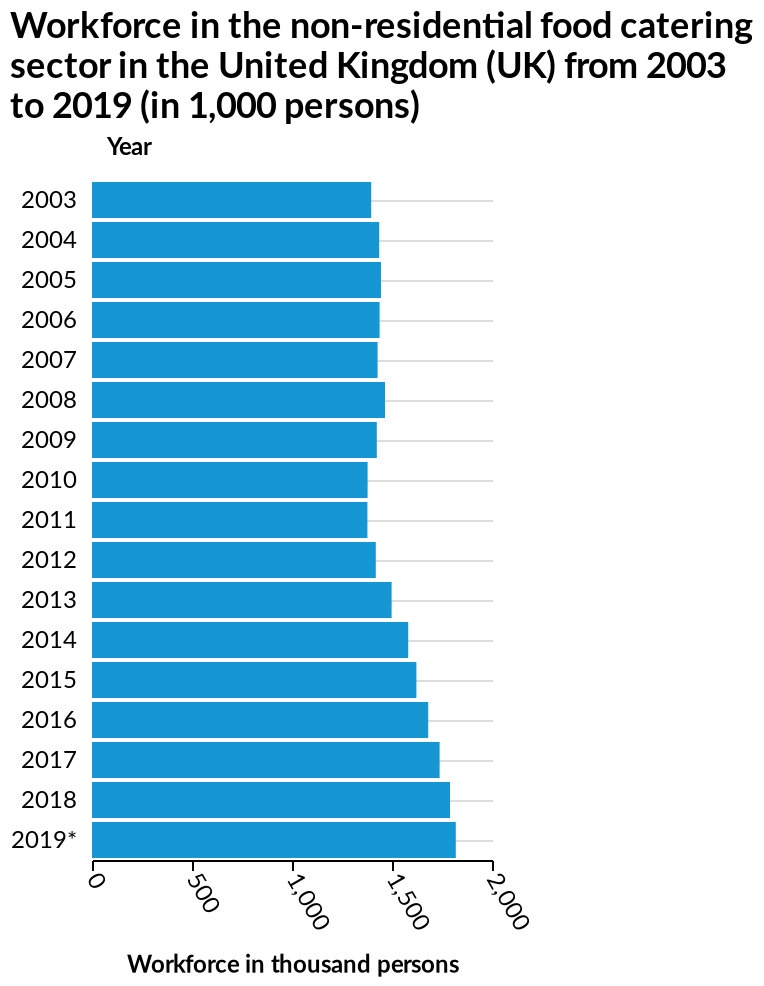<image>
What is the title of the bar graph?  The title of the bar graph is "Workforce in the non-residential food catering sector in the United Kingdom (UK) from 2003 to 2019 (in 1,000 persons)". Has the increase in the number of workforce been consistent over the years?  Yes, overall, there has been a consistent increase in the number of workforce over the years. What does the x-axis in the bar graph measure?  The x-axis in the bar graph measures Workforce in thousand persons. What does the y-axis in the bar graph plot?  The y-axis in the bar graph plots Year. Was there a decline in the number of workforce in 2010 and 2011?  Yes, there was a dip in the number of workforce in both 2010 and 2011. Is the title of the bar graph "Workforce in the residential food catering sector in the United States (US) from 2003 to 2019 (in 1,000 persons)"? No. The title of the bar graph is "Workforce in the non-residential food catering sector in the United Kingdom (UK) from 2003 to 2019 (in 1,000 persons)". 